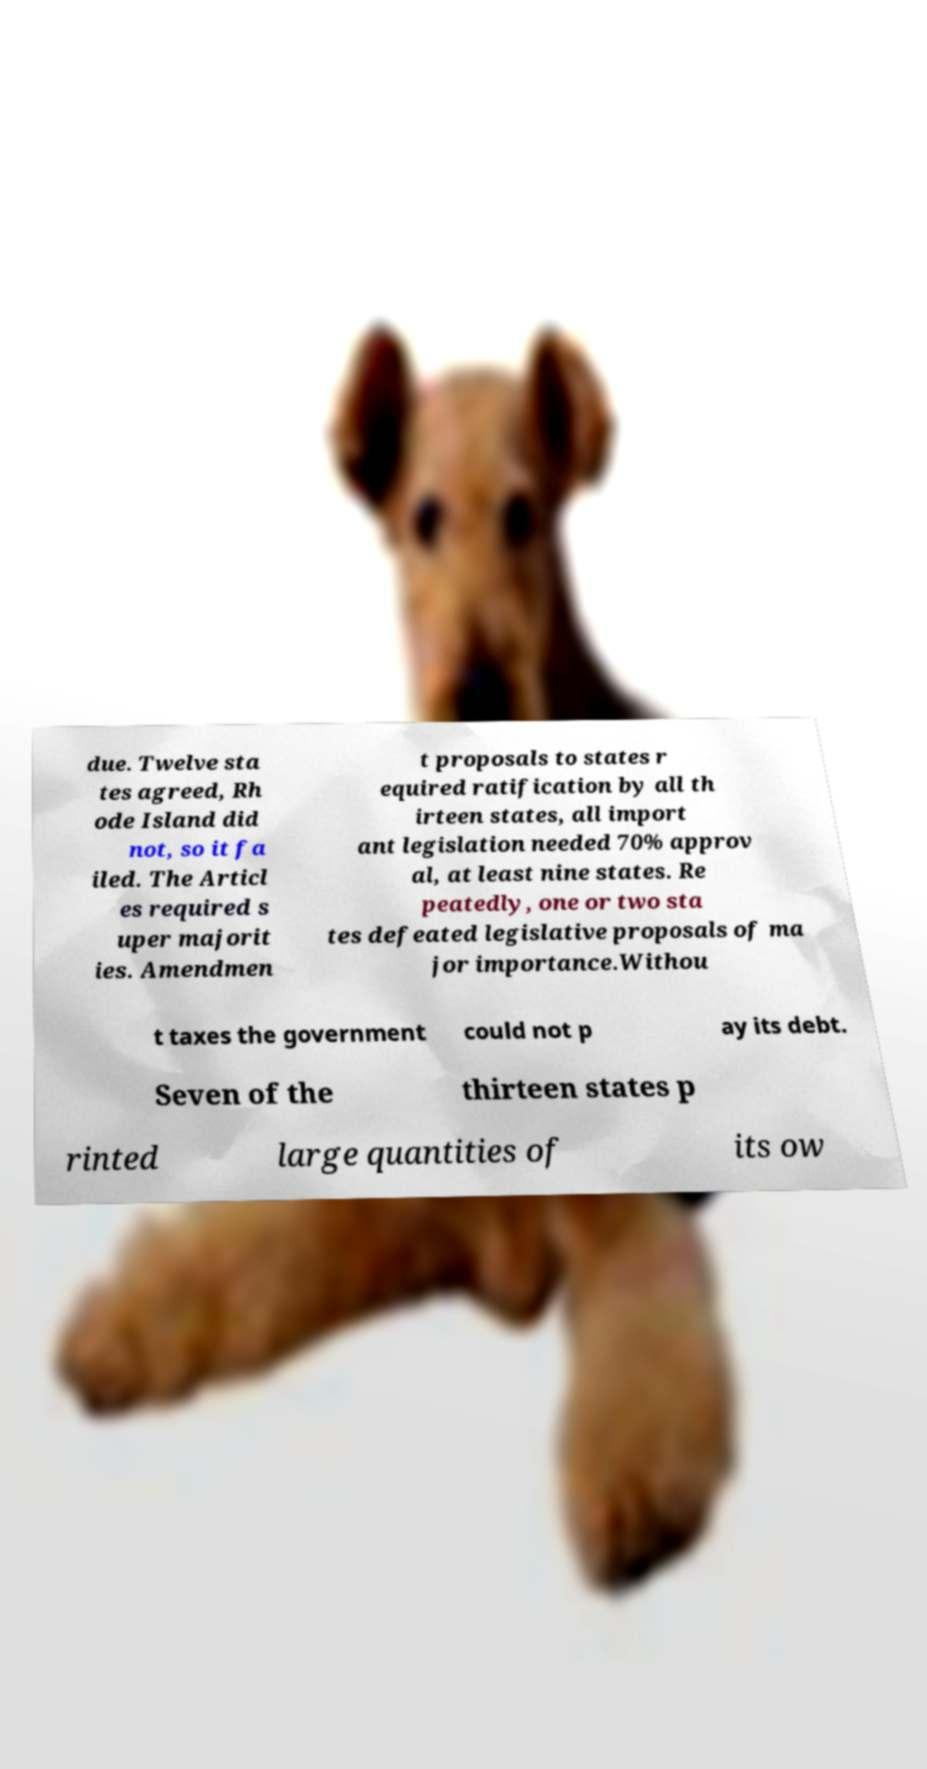There's text embedded in this image that I need extracted. Can you transcribe it verbatim? due. Twelve sta tes agreed, Rh ode Island did not, so it fa iled. The Articl es required s uper majorit ies. Amendmen t proposals to states r equired ratification by all th irteen states, all import ant legislation needed 70% approv al, at least nine states. Re peatedly, one or two sta tes defeated legislative proposals of ma jor importance.Withou t taxes the government could not p ay its debt. Seven of the thirteen states p rinted large quantities of its ow 